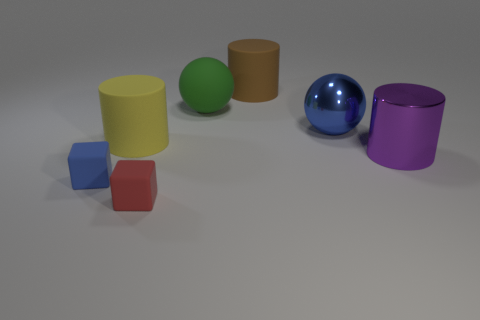What color is the big shiny object behind the large purple metal cylinder?
Your response must be concise. Blue. What is the shape of the big object that is behind the big ball that is left of the large brown matte cylinder?
Your answer should be very brief. Cylinder. Does the brown object have the same material as the blue thing that is behind the small blue rubber thing?
Provide a succinct answer. No. How many purple rubber blocks are the same size as the purple shiny cylinder?
Your answer should be compact. 0. Is the number of tiny red rubber cubes behind the blue rubber thing less than the number of big brown cylinders?
Make the answer very short. Yes. There is a yellow matte object; how many blue objects are to the right of it?
Make the answer very short. 1. There is a object that is to the right of the blue thing behind the large purple metallic cylinder on the right side of the red matte thing; what is its size?
Give a very brief answer. Large. There is a red object; is its shape the same as the large matte thing behind the rubber ball?
Offer a terse response. No. There is a blue thing that is the same material as the big yellow cylinder; what size is it?
Provide a short and direct response. Small. Is there any other thing that is the same color as the metal sphere?
Keep it short and to the point. Yes. 